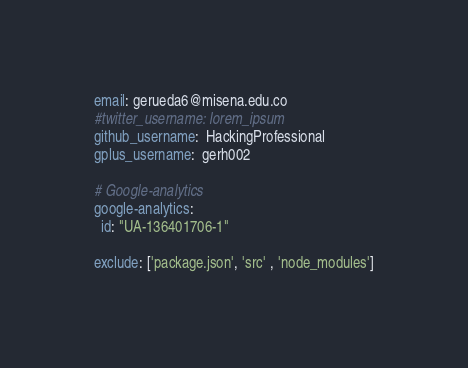Convert code to text. <code><loc_0><loc_0><loc_500><loc_500><_YAML_>email: gerueda6@misena.edu.co
#twitter_username: lorem_ipsum
github_username:  HackingProfessional
gplus_username:  gerh002

# Google-analytics
google-analytics:
  id: "UA-136401706-1"

exclude: ['package.json', 'src' , 'node_modules']
</code> 